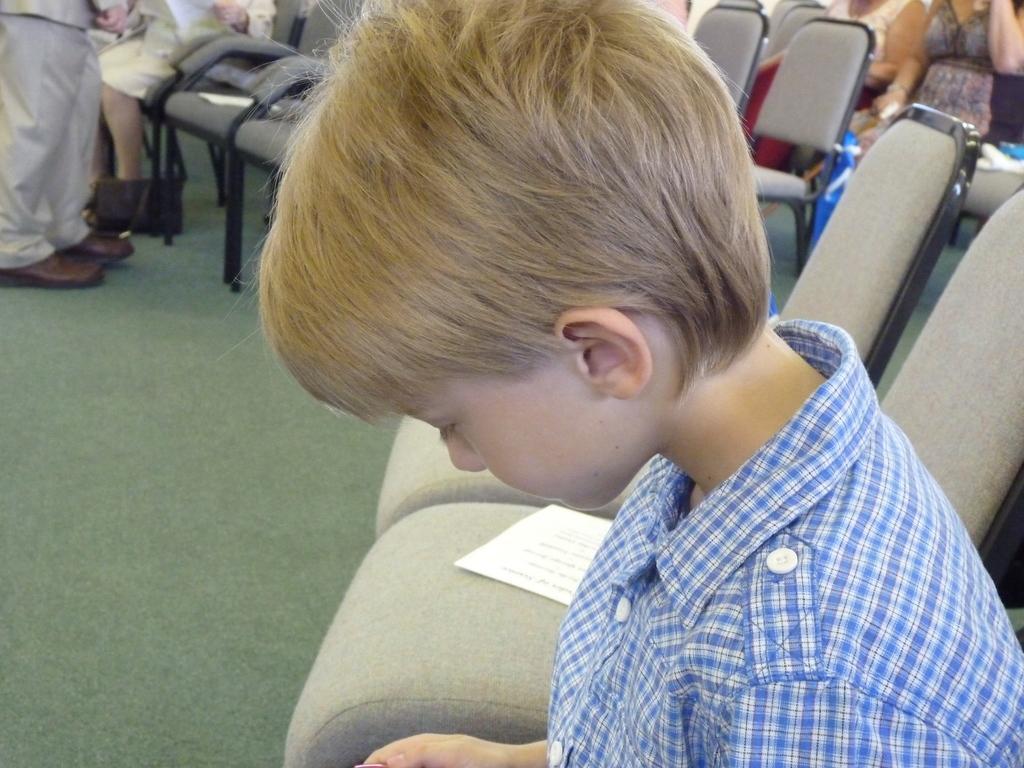In one or two sentences, can you explain what this image depicts? In this image we can see a boy. We can also see a paper on the chair. In the background we can see some women sitting on the chairs. We can also see the empty chairs and there is a man standing on the left. We can also see the floor. 